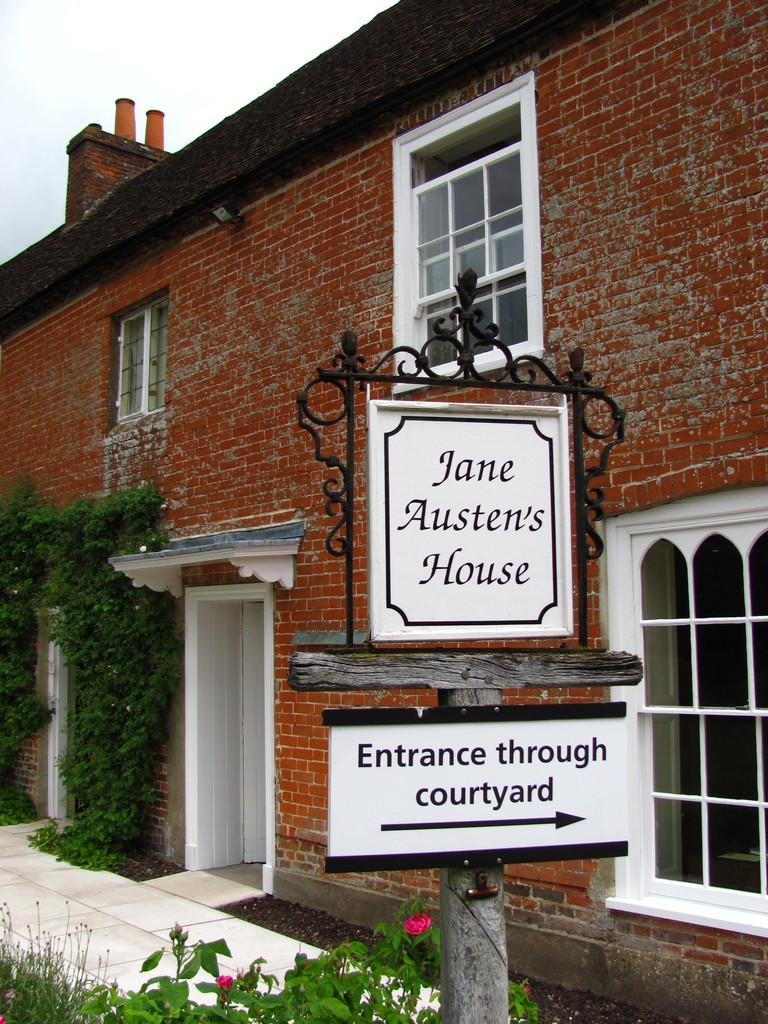What type of structure is in the image? There is a house in the image. What color are the bricks of the house? The house has red color bricks. What else can be seen in the image besides the house? There are plants and a sign board in the image. What is visible at the top of the image? The sky is visible at the top of the image. What type of fruit is being served at the feast in the image? There is no feast or fruit present in the image; it features a house with red color bricks, plants, a sign board, and a visible sky. What is the source of noise in the image? There is no noise or indication of a noise source in the image. 